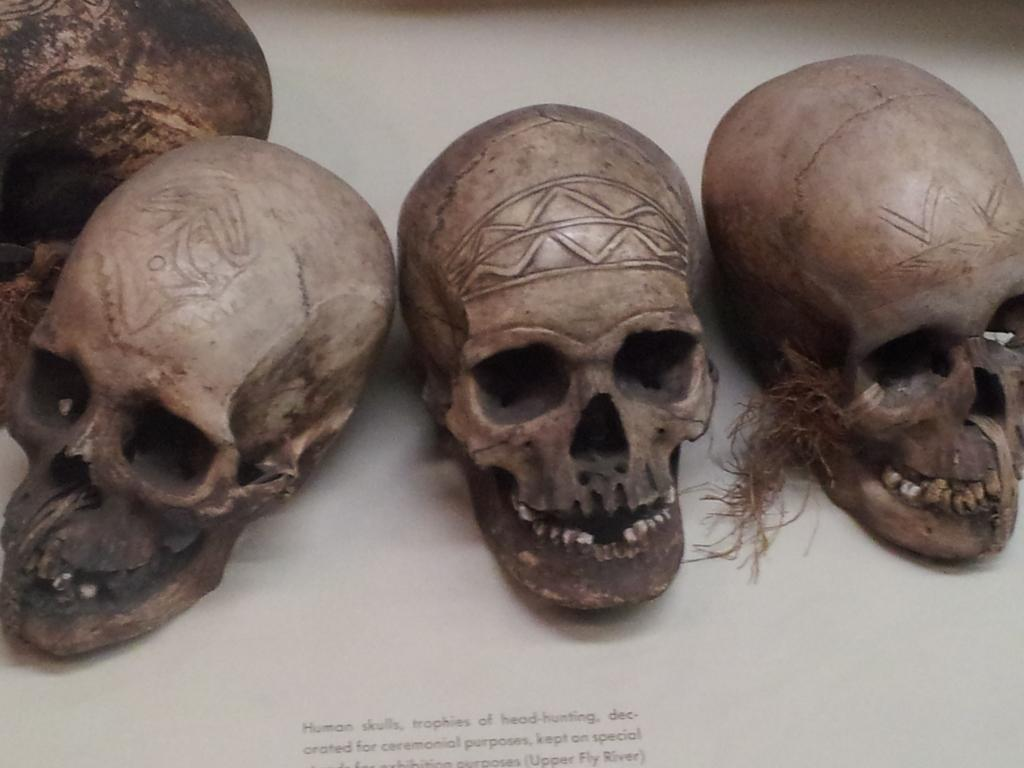How many skulls are present in the image? There are four skulls in the image. Where are the skulls located? The skulls are on a table. Is there any text or writing in the image? Yes, there is writing at the bottom of the image. What type of quiet monkey can be seen in the image? There is no monkey present in the image; it features four skulls on a table and writing at the bottom. 